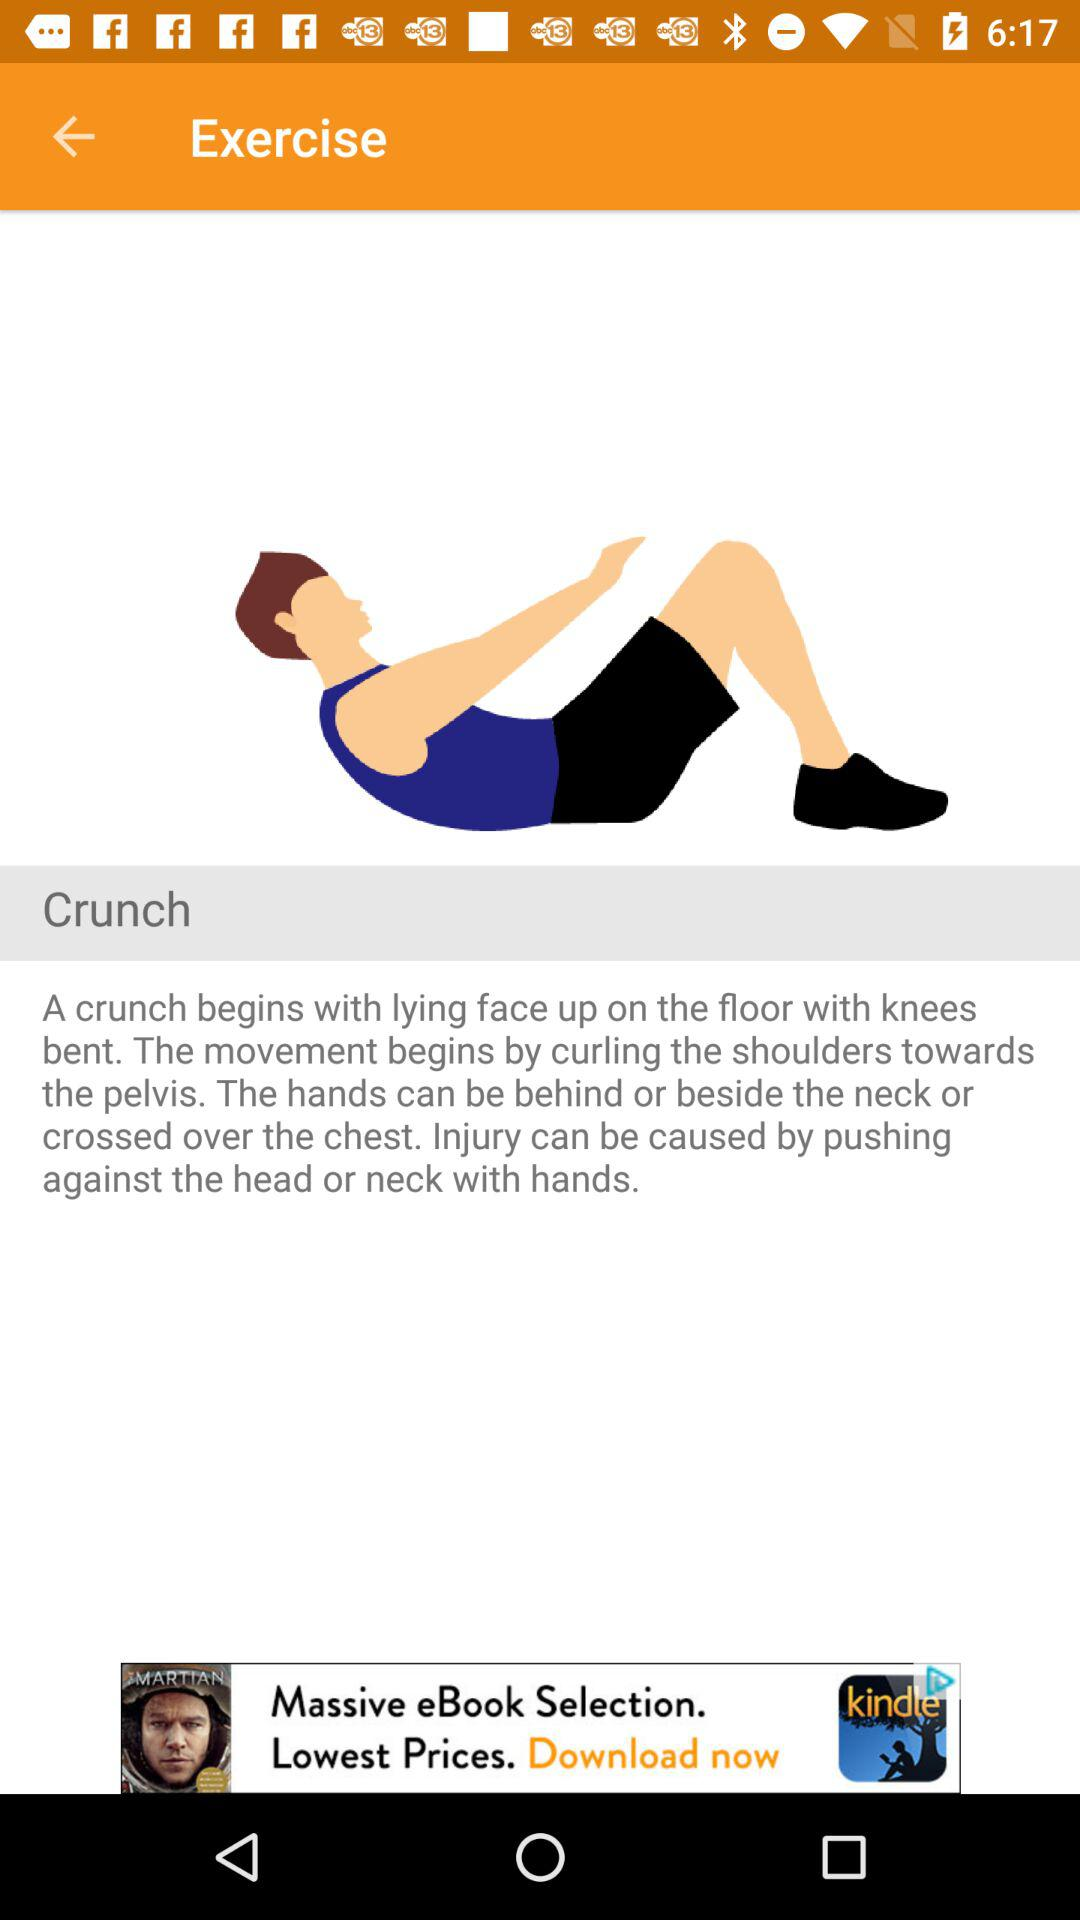What is the name of the exercise? The name of the exercise is Crunch. 